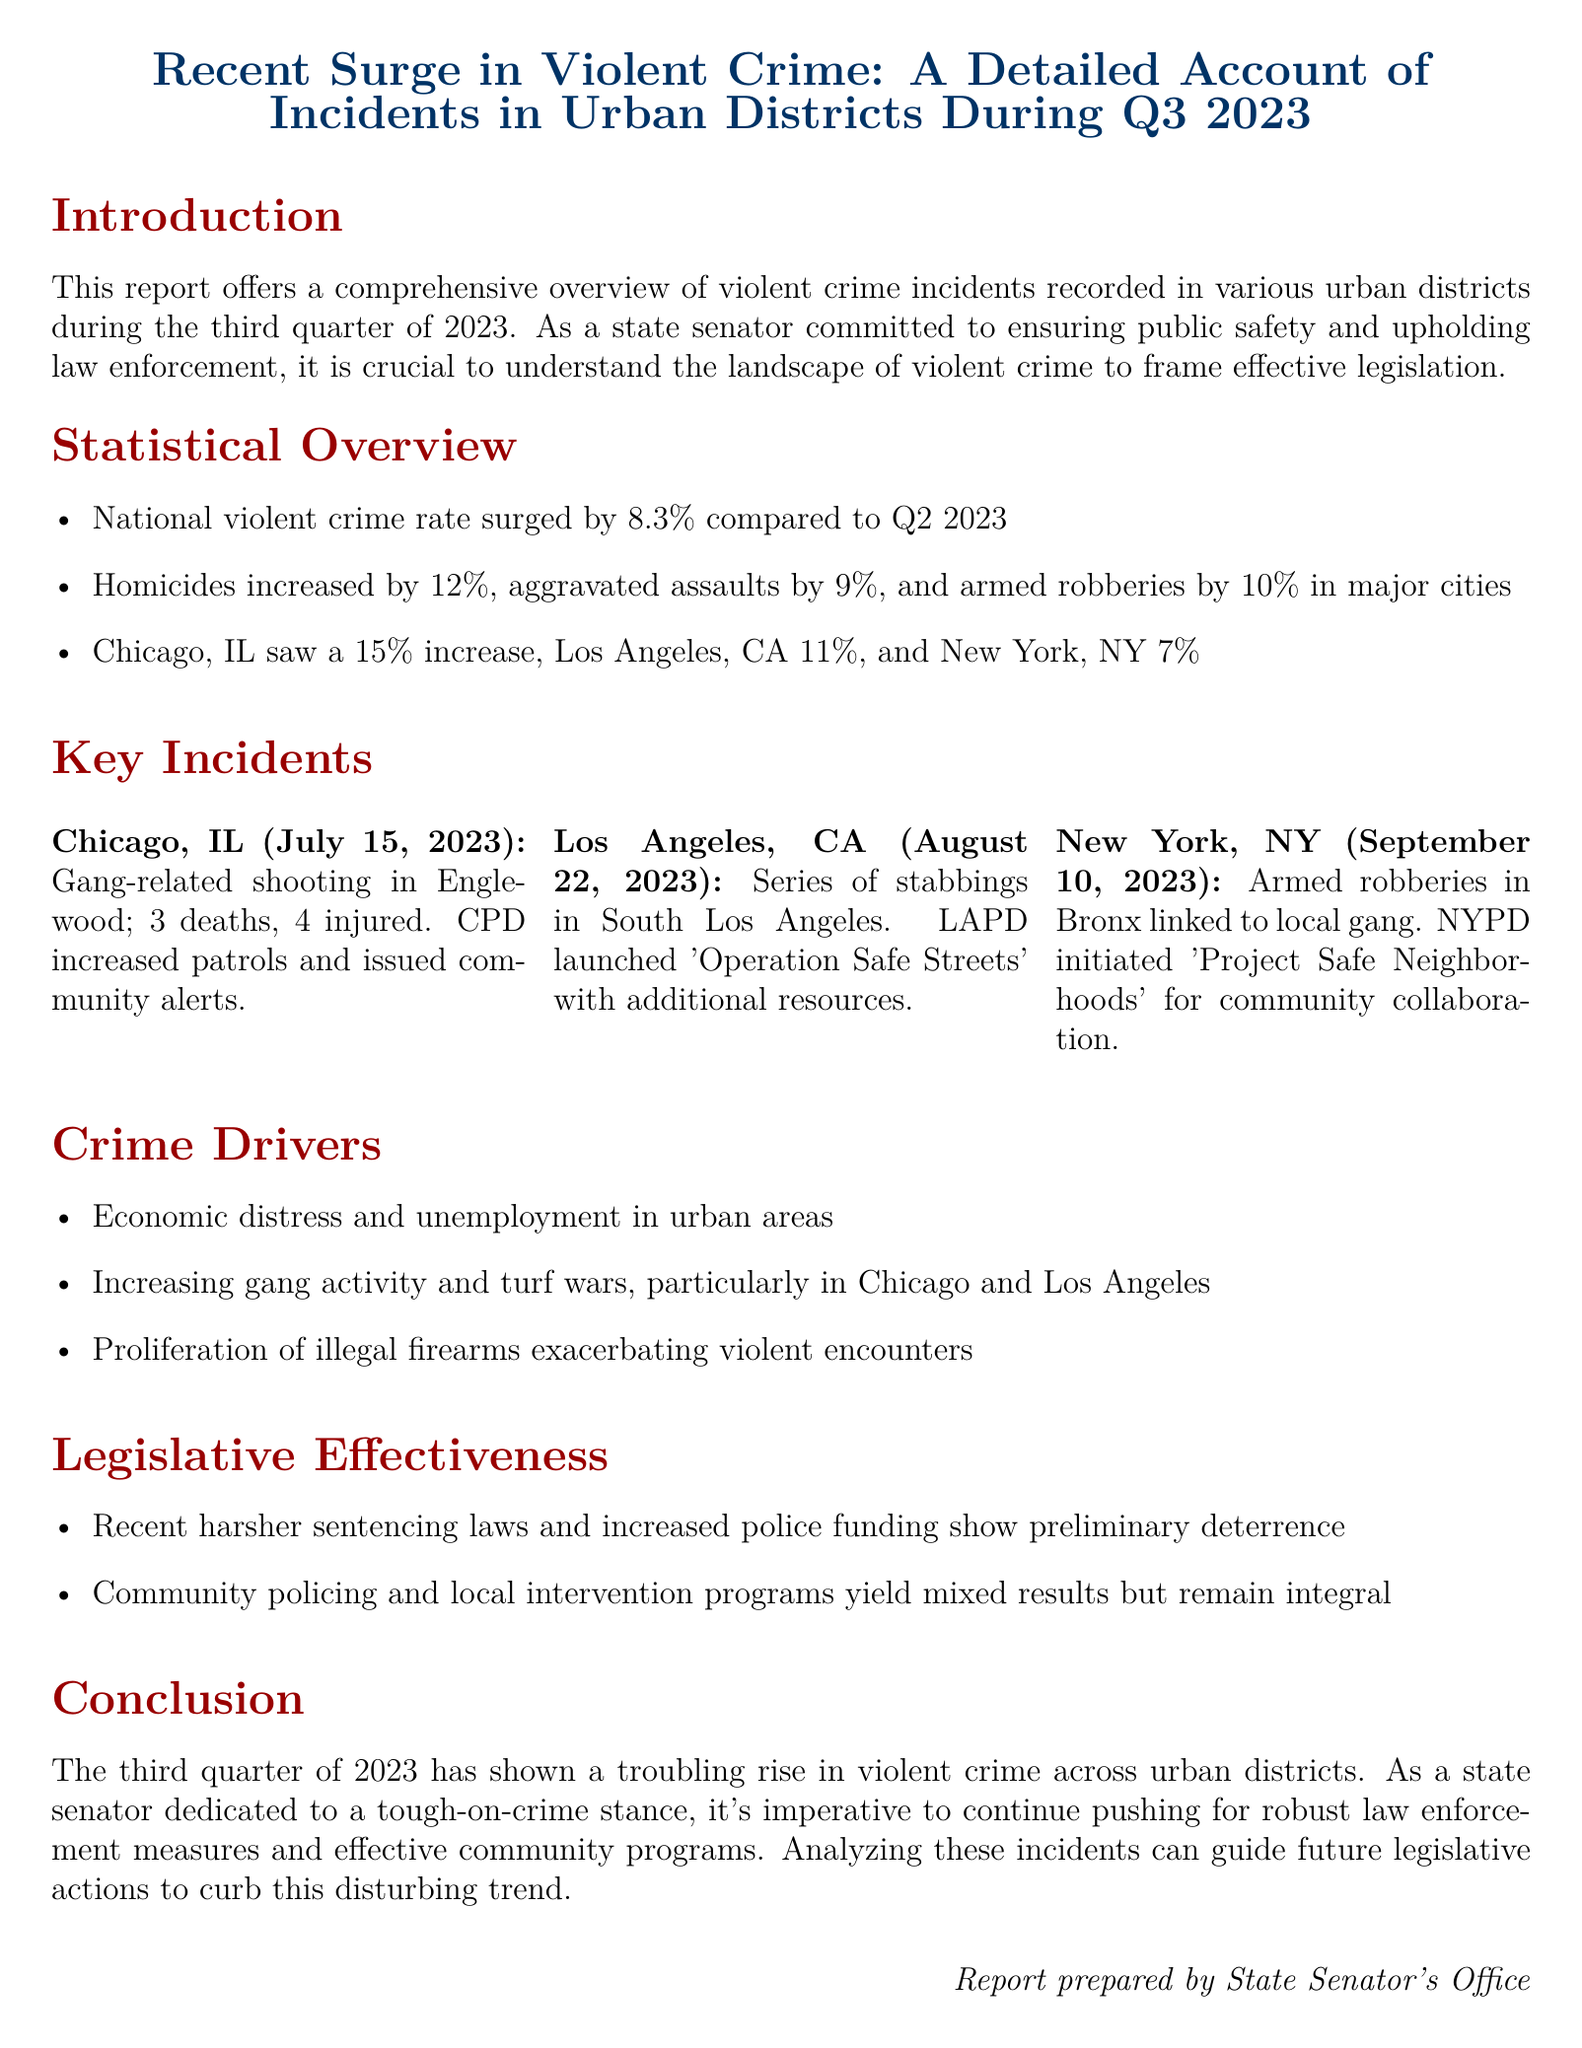What is the percentage increase in national violent crime rate? The document states that the national violent crime rate surged by 8.3% compared to Q2 2023.
Answer: 8.3% What city had the highest increase in violent crime incidents? According to the document, Chicago, IL saw a 15% increase in violent crime incidents.
Answer: Chicago, IL How many deaths occurred in the gang-related shooting in Chicago? The report indicates that there were 3 deaths in the gang-related shooting in Englewood.
Answer: 3 What operation did LAPD launch in response to stabbings? The document mentions that LAPD launched 'Operation Safe Streets' in response to the stabbings.
Answer: Operation Safe Streets What are two identified crime drivers mentioned in the report? The report identifies economic distress and increasing gang activity as crime drivers.
Answer: Economic distress, increasing gang activity What was the percentage increase in homicides? The report specifies that homicides increased by 12% during Q3 2023.
Answer: 12% What community initiative did NYPD initiate to address armed robberies? The document states that NYPD initiated 'Project Safe Neighborhoods' for community collaboration.
Answer: Project Safe Neighborhoods What is the primary goal of the report as stated in the introduction? The introduction mentions that the goal is to understand the landscape of violent crime to frame effective legislation.
Answer: Frame effective legislation 